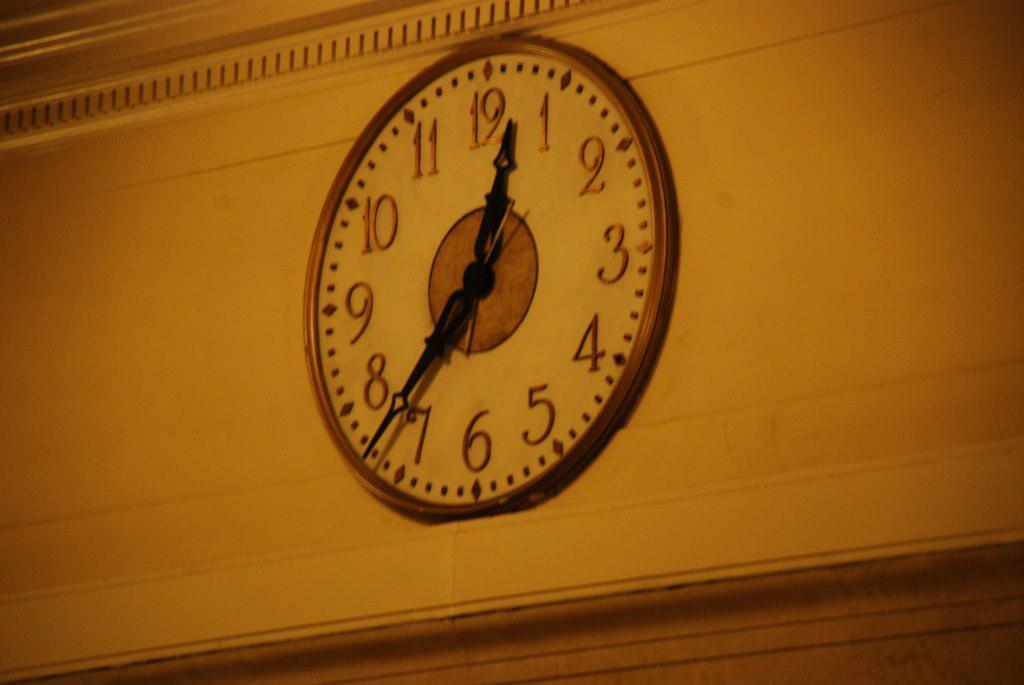<image>
Write a terse but informative summary of the picture. A clock hanging on a white brick wall shows the time as 12:37. 